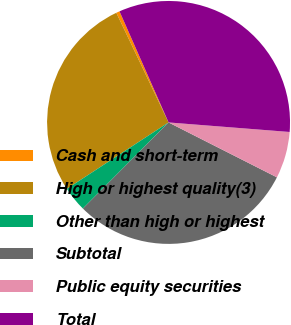Convert chart. <chart><loc_0><loc_0><loc_500><loc_500><pie_chart><fcel>Cash and short-term<fcel>High or highest quality(3)<fcel>Other than high or highest<fcel>Subtotal<fcel>Public equity securities<fcel>Total<nl><fcel>0.46%<fcel>27.13%<fcel>3.33%<fcel>30.0%<fcel>6.21%<fcel>32.87%<nl></chart> 